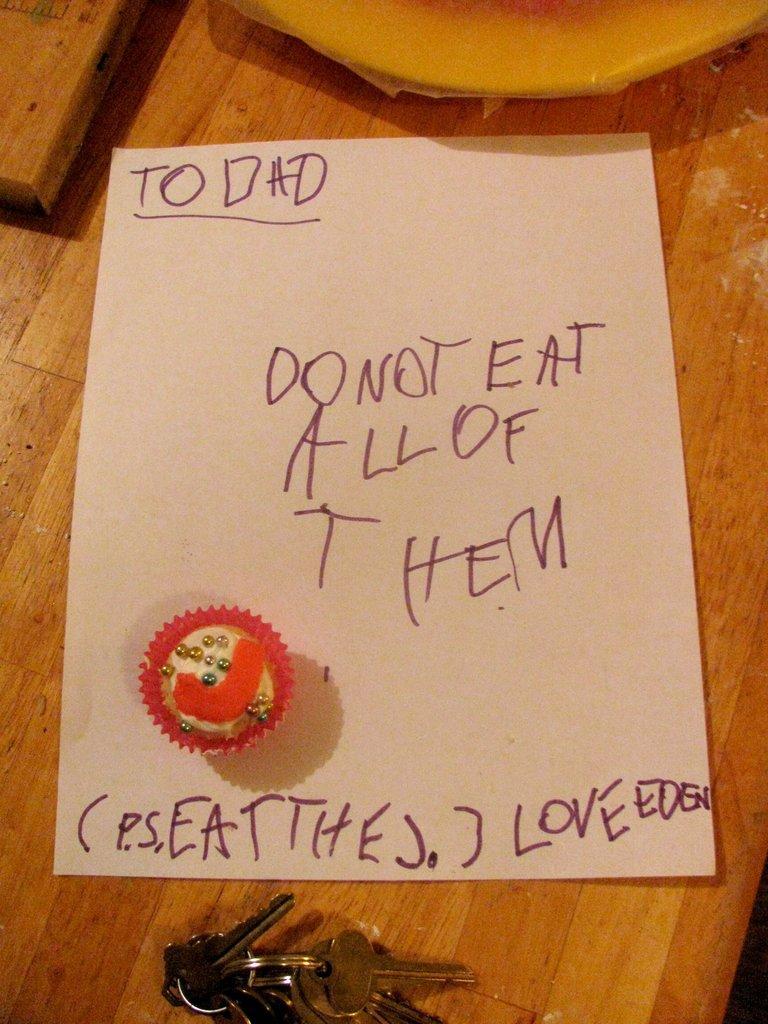How would you summarize this image in a sentence or two? In this picture I can see the brown color surface on which there is a paper and I see something is written and I see the keys on the bottom of this image and I see a red and white color thing on the paper. 